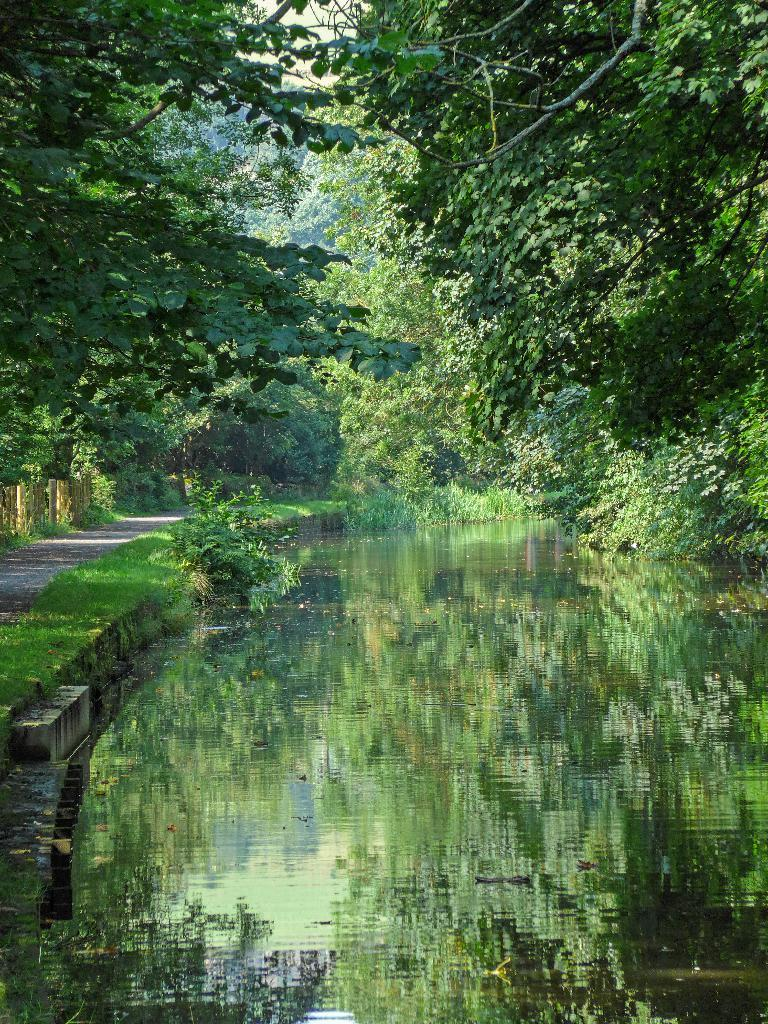What natural feature is located at the bottom of the image? There is a river at the bottom of the image. What man-made feature is on the left side of the image? There is a road on the left side of the image. What type of vegetation is visible beside the road? Grass is visible beside the road. What structures are present beside the road? There are poles present beside the road. What can be seen in the background of the image? There are many trees in the background of the image. How many chairs are visible in the image? There are no chairs present in the image. What is the distance between the river and the trees in the background? The distance between the river and the trees in the background cannot be determined from the image alone, as there is no scale provided. 